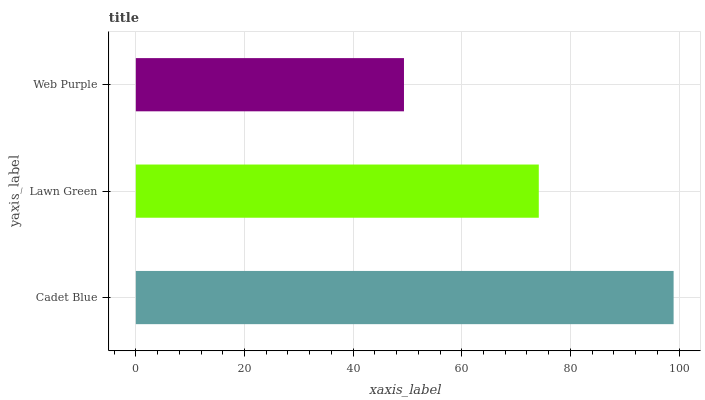Is Web Purple the minimum?
Answer yes or no. Yes. Is Cadet Blue the maximum?
Answer yes or no. Yes. Is Lawn Green the minimum?
Answer yes or no. No. Is Lawn Green the maximum?
Answer yes or no. No. Is Cadet Blue greater than Lawn Green?
Answer yes or no. Yes. Is Lawn Green less than Cadet Blue?
Answer yes or no. Yes. Is Lawn Green greater than Cadet Blue?
Answer yes or no. No. Is Cadet Blue less than Lawn Green?
Answer yes or no. No. Is Lawn Green the high median?
Answer yes or no. Yes. Is Lawn Green the low median?
Answer yes or no. Yes. Is Web Purple the high median?
Answer yes or no. No. Is Web Purple the low median?
Answer yes or no. No. 